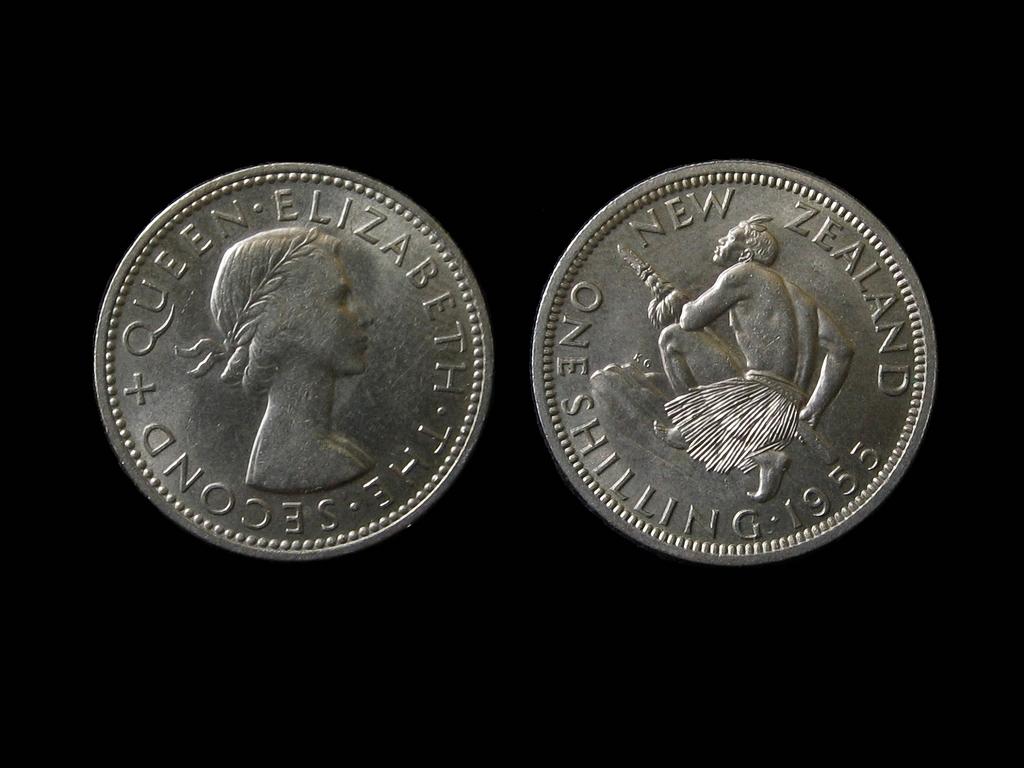Where is this coin from?
Offer a very short reply. New zealand. What country is this coin from?
Offer a very short reply. New zealand. 